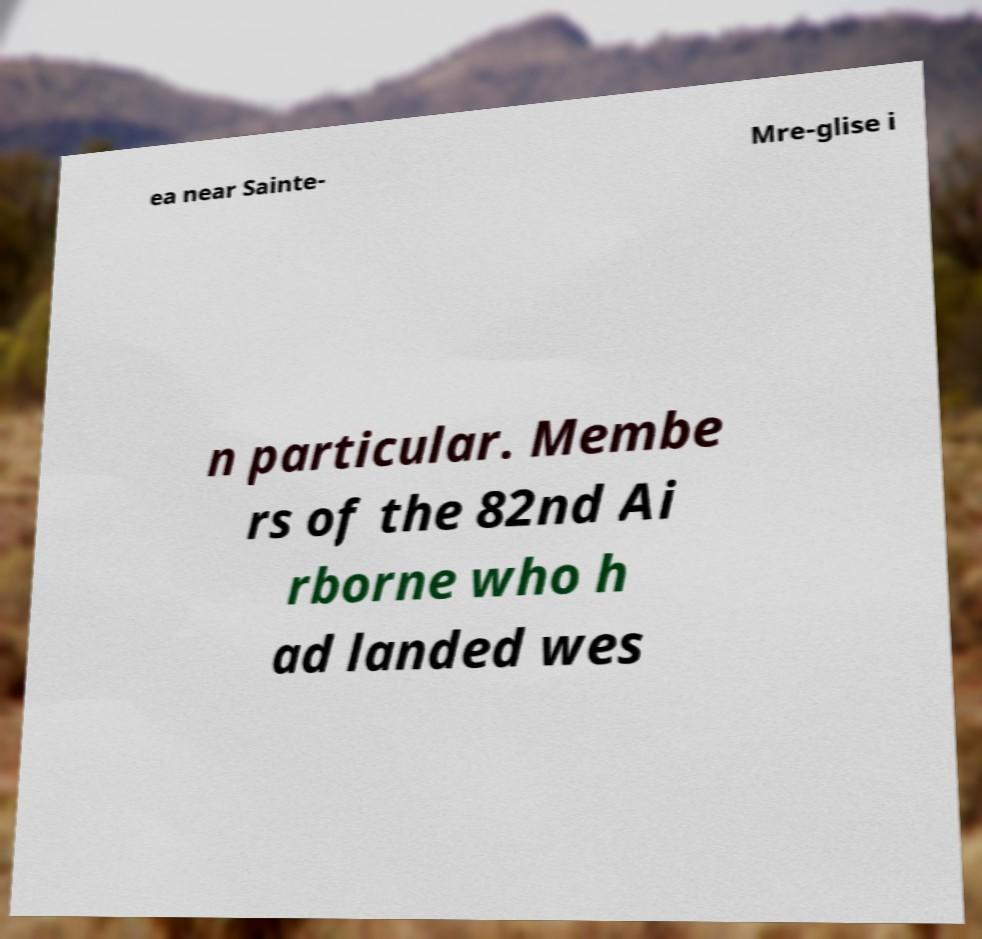Please read and relay the text visible in this image. What does it say? ea near Sainte- Mre-glise i n particular. Membe rs of the 82nd Ai rborne who h ad landed wes 